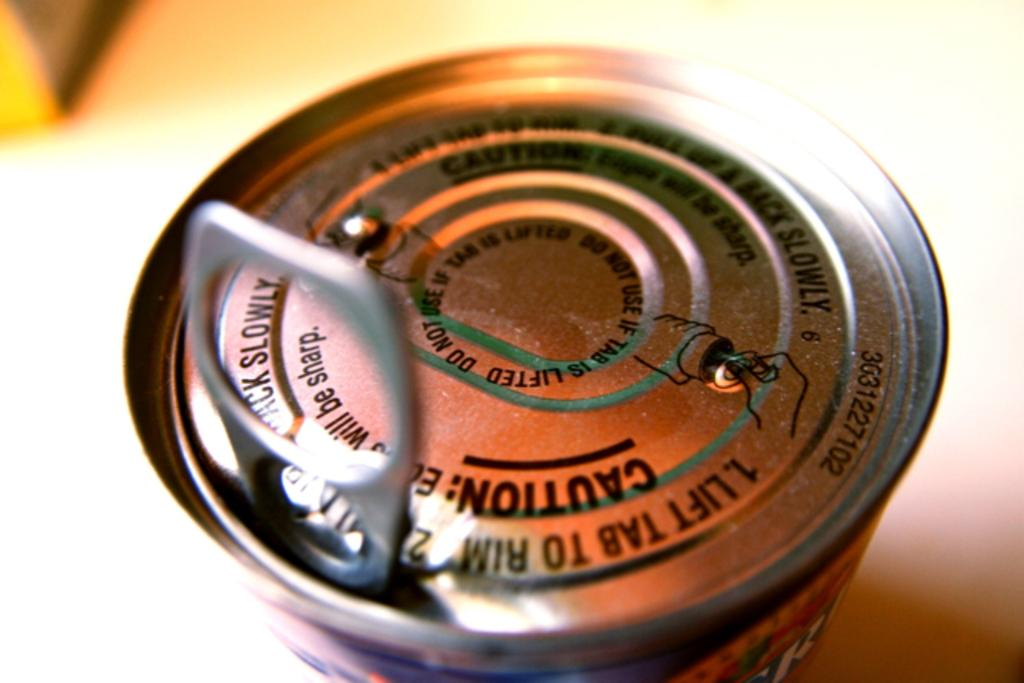What object is featured in the image with a holder? There is a tin with a holder in the image. What can be seen on the tin's surface? There is text and figures on the tin. What is visible at the bottom of the image? The surface is visible at the bottom of the image. How would you describe the background of the image? The background has a blurred view. What type of journey is depicted in the image? There is no journey depicted in the image; it features a tin with a holder and text and figures on its surface. Where is the meeting taking place in the image? There is no meeting present in the image; it only shows a tin with a holder and a blurred background. 